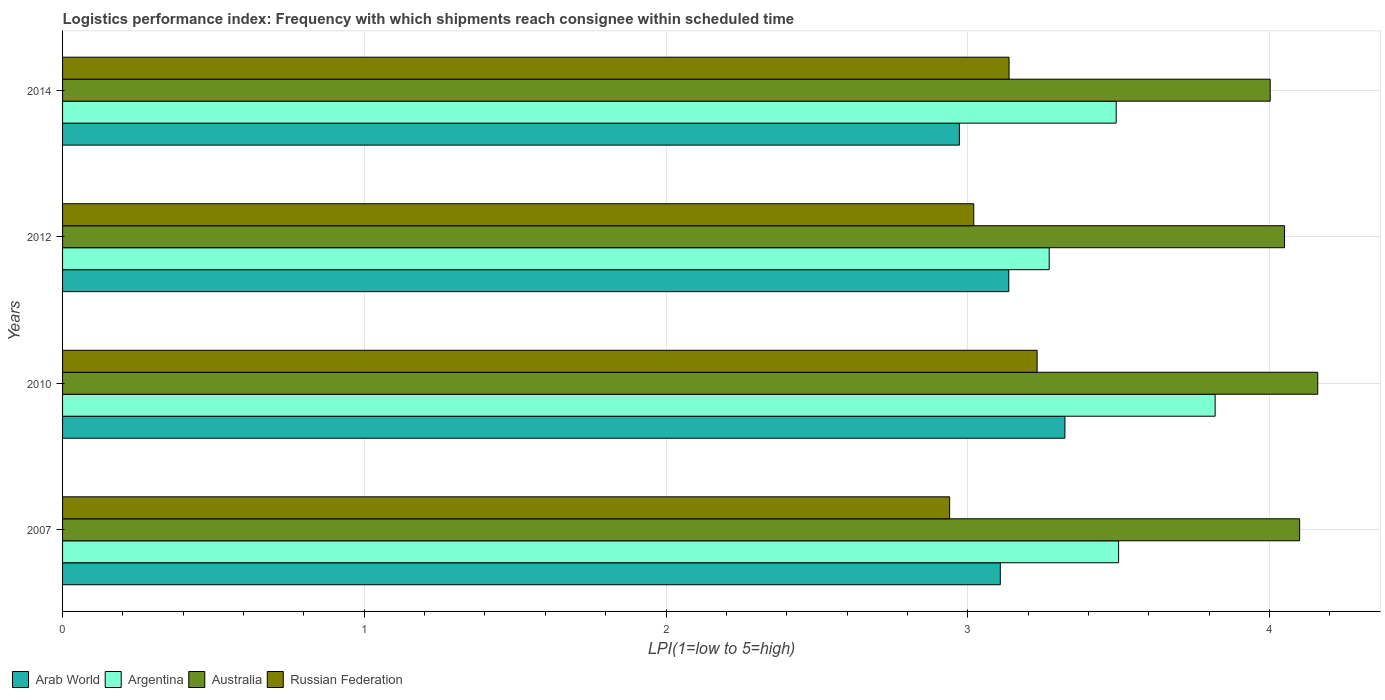Are the number of bars per tick equal to the number of legend labels?
Your response must be concise. Yes. How many bars are there on the 2nd tick from the top?
Your answer should be compact. 4. What is the logistics performance index in Australia in 2012?
Give a very brief answer. 4.05. Across all years, what is the maximum logistics performance index in Argentina?
Offer a terse response. 3.82. Across all years, what is the minimum logistics performance index in Arab World?
Make the answer very short. 2.97. What is the total logistics performance index in Arab World in the graph?
Provide a succinct answer. 12.54. What is the difference between the logistics performance index in Argentina in 2007 and that in 2012?
Make the answer very short. 0.23. What is the difference between the logistics performance index in Arab World in 2007 and the logistics performance index in Russian Federation in 2012?
Provide a short and direct response. 0.09. What is the average logistics performance index in Argentina per year?
Your response must be concise. 3.52. In the year 2010, what is the difference between the logistics performance index in Arab World and logistics performance index in Argentina?
Give a very brief answer. -0.5. In how many years, is the logistics performance index in Australia greater than 2.6 ?
Your answer should be very brief. 4. What is the ratio of the logistics performance index in Australia in 2007 to that in 2010?
Your answer should be compact. 0.99. What is the difference between the highest and the second highest logistics performance index in Argentina?
Your response must be concise. 0.32. What is the difference between the highest and the lowest logistics performance index in Argentina?
Your response must be concise. 0.55. In how many years, is the logistics performance index in Russian Federation greater than the average logistics performance index in Russian Federation taken over all years?
Offer a very short reply. 2. Is the sum of the logistics performance index in Arab World in 2012 and 2014 greater than the maximum logistics performance index in Russian Federation across all years?
Keep it short and to the point. Yes. Is it the case that in every year, the sum of the logistics performance index in Australia and logistics performance index in Russian Federation is greater than the sum of logistics performance index in Argentina and logistics performance index in Arab World?
Give a very brief answer. Yes. What does the 4th bar from the top in 2012 represents?
Your response must be concise. Arab World. How many bars are there?
Offer a very short reply. 16. Are all the bars in the graph horizontal?
Your response must be concise. Yes. How are the legend labels stacked?
Provide a succinct answer. Horizontal. What is the title of the graph?
Provide a short and direct response. Logistics performance index: Frequency with which shipments reach consignee within scheduled time. Does "Bahrain" appear as one of the legend labels in the graph?
Your answer should be very brief. No. What is the label or title of the X-axis?
Provide a short and direct response. LPI(1=low to 5=high). What is the LPI(1=low to 5=high) in Arab World in 2007?
Your response must be concise. 3.11. What is the LPI(1=low to 5=high) in Argentina in 2007?
Keep it short and to the point. 3.5. What is the LPI(1=low to 5=high) of Russian Federation in 2007?
Offer a very short reply. 2.94. What is the LPI(1=low to 5=high) in Arab World in 2010?
Your answer should be compact. 3.32. What is the LPI(1=low to 5=high) in Argentina in 2010?
Offer a very short reply. 3.82. What is the LPI(1=low to 5=high) in Australia in 2010?
Keep it short and to the point. 4.16. What is the LPI(1=low to 5=high) in Russian Federation in 2010?
Your answer should be compact. 3.23. What is the LPI(1=low to 5=high) in Arab World in 2012?
Provide a short and direct response. 3.14. What is the LPI(1=low to 5=high) in Argentina in 2012?
Ensure brevity in your answer.  3.27. What is the LPI(1=low to 5=high) of Australia in 2012?
Provide a succinct answer. 4.05. What is the LPI(1=low to 5=high) in Russian Federation in 2012?
Your answer should be compact. 3.02. What is the LPI(1=low to 5=high) of Arab World in 2014?
Keep it short and to the point. 2.97. What is the LPI(1=low to 5=high) of Argentina in 2014?
Your answer should be compact. 3.49. What is the LPI(1=low to 5=high) of Australia in 2014?
Make the answer very short. 4. What is the LPI(1=low to 5=high) of Russian Federation in 2014?
Offer a very short reply. 3.14. Across all years, what is the maximum LPI(1=low to 5=high) of Arab World?
Give a very brief answer. 3.32. Across all years, what is the maximum LPI(1=low to 5=high) of Argentina?
Provide a succinct answer. 3.82. Across all years, what is the maximum LPI(1=low to 5=high) of Australia?
Give a very brief answer. 4.16. Across all years, what is the maximum LPI(1=low to 5=high) in Russian Federation?
Ensure brevity in your answer.  3.23. Across all years, what is the minimum LPI(1=low to 5=high) in Arab World?
Your answer should be compact. 2.97. Across all years, what is the minimum LPI(1=low to 5=high) of Argentina?
Ensure brevity in your answer.  3.27. Across all years, what is the minimum LPI(1=low to 5=high) in Australia?
Offer a terse response. 4. Across all years, what is the minimum LPI(1=low to 5=high) in Russian Federation?
Offer a terse response. 2.94. What is the total LPI(1=low to 5=high) in Arab World in the graph?
Give a very brief answer. 12.54. What is the total LPI(1=low to 5=high) of Argentina in the graph?
Keep it short and to the point. 14.08. What is the total LPI(1=low to 5=high) in Australia in the graph?
Offer a terse response. 16.31. What is the total LPI(1=low to 5=high) of Russian Federation in the graph?
Your answer should be compact. 12.33. What is the difference between the LPI(1=low to 5=high) in Arab World in 2007 and that in 2010?
Provide a short and direct response. -0.21. What is the difference between the LPI(1=low to 5=high) of Argentina in 2007 and that in 2010?
Keep it short and to the point. -0.32. What is the difference between the LPI(1=low to 5=high) of Australia in 2007 and that in 2010?
Ensure brevity in your answer.  -0.06. What is the difference between the LPI(1=low to 5=high) in Russian Federation in 2007 and that in 2010?
Your answer should be very brief. -0.29. What is the difference between the LPI(1=low to 5=high) of Arab World in 2007 and that in 2012?
Your answer should be very brief. -0.03. What is the difference between the LPI(1=low to 5=high) in Argentina in 2007 and that in 2012?
Offer a terse response. 0.23. What is the difference between the LPI(1=low to 5=high) of Russian Federation in 2007 and that in 2012?
Keep it short and to the point. -0.08. What is the difference between the LPI(1=low to 5=high) in Arab World in 2007 and that in 2014?
Your response must be concise. 0.14. What is the difference between the LPI(1=low to 5=high) in Argentina in 2007 and that in 2014?
Provide a succinct answer. 0.01. What is the difference between the LPI(1=low to 5=high) in Australia in 2007 and that in 2014?
Provide a succinct answer. 0.1. What is the difference between the LPI(1=low to 5=high) of Russian Federation in 2007 and that in 2014?
Keep it short and to the point. -0.2. What is the difference between the LPI(1=low to 5=high) in Arab World in 2010 and that in 2012?
Ensure brevity in your answer.  0.19. What is the difference between the LPI(1=low to 5=high) of Argentina in 2010 and that in 2012?
Offer a terse response. 0.55. What is the difference between the LPI(1=low to 5=high) of Australia in 2010 and that in 2012?
Provide a short and direct response. 0.11. What is the difference between the LPI(1=low to 5=high) in Russian Federation in 2010 and that in 2012?
Your answer should be compact. 0.21. What is the difference between the LPI(1=low to 5=high) of Arab World in 2010 and that in 2014?
Provide a short and direct response. 0.35. What is the difference between the LPI(1=low to 5=high) in Argentina in 2010 and that in 2014?
Make the answer very short. 0.33. What is the difference between the LPI(1=low to 5=high) of Australia in 2010 and that in 2014?
Keep it short and to the point. 0.16. What is the difference between the LPI(1=low to 5=high) of Russian Federation in 2010 and that in 2014?
Offer a terse response. 0.09. What is the difference between the LPI(1=low to 5=high) of Arab World in 2012 and that in 2014?
Offer a very short reply. 0.16. What is the difference between the LPI(1=low to 5=high) of Argentina in 2012 and that in 2014?
Your answer should be compact. -0.22. What is the difference between the LPI(1=low to 5=high) of Australia in 2012 and that in 2014?
Your response must be concise. 0.05. What is the difference between the LPI(1=low to 5=high) of Russian Federation in 2012 and that in 2014?
Offer a terse response. -0.12. What is the difference between the LPI(1=low to 5=high) of Arab World in 2007 and the LPI(1=low to 5=high) of Argentina in 2010?
Your answer should be very brief. -0.71. What is the difference between the LPI(1=low to 5=high) of Arab World in 2007 and the LPI(1=low to 5=high) of Australia in 2010?
Your answer should be compact. -1.05. What is the difference between the LPI(1=low to 5=high) of Arab World in 2007 and the LPI(1=low to 5=high) of Russian Federation in 2010?
Make the answer very short. -0.12. What is the difference between the LPI(1=low to 5=high) of Argentina in 2007 and the LPI(1=low to 5=high) of Australia in 2010?
Offer a terse response. -0.66. What is the difference between the LPI(1=low to 5=high) in Argentina in 2007 and the LPI(1=low to 5=high) in Russian Federation in 2010?
Give a very brief answer. 0.27. What is the difference between the LPI(1=low to 5=high) in Australia in 2007 and the LPI(1=low to 5=high) in Russian Federation in 2010?
Provide a short and direct response. 0.87. What is the difference between the LPI(1=low to 5=high) of Arab World in 2007 and the LPI(1=low to 5=high) of Argentina in 2012?
Your answer should be compact. -0.16. What is the difference between the LPI(1=low to 5=high) in Arab World in 2007 and the LPI(1=low to 5=high) in Australia in 2012?
Your answer should be compact. -0.94. What is the difference between the LPI(1=low to 5=high) in Arab World in 2007 and the LPI(1=low to 5=high) in Russian Federation in 2012?
Offer a very short reply. 0.09. What is the difference between the LPI(1=low to 5=high) in Argentina in 2007 and the LPI(1=low to 5=high) in Australia in 2012?
Make the answer very short. -0.55. What is the difference between the LPI(1=low to 5=high) of Argentina in 2007 and the LPI(1=low to 5=high) of Russian Federation in 2012?
Keep it short and to the point. 0.48. What is the difference between the LPI(1=low to 5=high) in Australia in 2007 and the LPI(1=low to 5=high) in Russian Federation in 2012?
Your answer should be very brief. 1.08. What is the difference between the LPI(1=low to 5=high) of Arab World in 2007 and the LPI(1=low to 5=high) of Argentina in 2014?
Offer a very short reply. -0.38. What is the difference between the LPI(1=low to 5=high) in Arab World in 2007 and the LPI(1=low to 5=high) in Australia in 2014?
Provide a succinct answer. -0.89. What is the difference between the LPI(1=low to 5=high) of Arab World in 2007 and the LPI(1=low to 5=high) of Russian Federation in 2014?
Your response must be concise. -0.03. What is the difference between the LPI(1=low to 5=high) of Argentina in 2007 and the LPI(1=low to 5=high) of Australia in 2014?
Keep it short and to the point. -0.5. What is the difference between the LPI(1=low to 5=high) in Argentina in 2007 and the LPI(1=low to 5=high) in Russian Federation in 2014?
Ensure brevity in your answer.  0.36. What is the difference between the LPI(1=low to 5=high) of Arab World in 2010 and the LPI(1=low to 5=high) of Argentina in 2012?
Give a very brief answer. 0.05. What is the difference between the LPI(1=low to 5=high) of Arab World in 2010 and the LPI(1=low to 5=high) of Australia in 2012?
Offer a very short reply. -0.73. What is the difference between the LPI(1=low to 5=high) in Arab World in 2010 and the LPI(1=low to 5=high) in Russian Federation in 2012?
Provide a succinct answer. 0.3. What is the difference between the LPI(1=low to 5=high) of Argentina in 2010 and the LPI(1=low to 5=high) of Australia in 2012?
Your response must be concise. -0.23. What is the difference between the LPI(1=low to 5=high) in Argentina in 2010 and the LPI(1=low to 5=high) in Russian Federation in 2012?
Keep it short and to the point. 0.8. What is the difference between the LPI(1=low to 5=high) of Australia in 2010 and the LPI(1=low to 5=high) of Russian Federation in 2012?
Provide a succinct answer. 1.14. What is the difference between the LPI(1=low to 5=high) in Arab World in 2010 and the LPI(1=low to 5=high) in Argentina in 2014?
Make the answer very short. -0.17. What is the difference between the LPI(1=low to 5=high) in Arab World in 2010 and the LPI(1=low to 5=high) in Australia in 2014?
Offer a terse response. -0.68. What is the difference between the LPI(1=low to 5=high) in Arab World in 2010 and the LPI(1=low to 5=high) in Russian Federation in 2014?
Your response must be concise. 0.19. What is the difference between the LPI(1=low to 5=high) in Argentina in 2010 and the LPI(1=low to 5=high) in Australia in 2014?
Provide a short and direct response. -0.18. What is the difference between the LPI(1=low to 5=high) in Argentina in 2010 and the LPI(1=low to 5=high) in Russian Federation in 2014?
Make the answer very short. 0.68. What is the difference between the LPI(1=low to 5=high) in Australia in 2010 and the LPI(1=low to 5=high) in Russian Federation in 2014?
Ensure brevity in your answer.  1.02. What is the difference between the LPI(1=low to 5=high) in Arab World in 2012 and the LPI(1=low to 5=high) in Argentina in 2014?
Offer a very short reply. -0.36. What is the difference between the LPI(1=low to 5=high) of Arab World in 2012 and the LPI(1=low to 5=high) of Australia in 2014?
Provide a short and direct response. -0.87. What is the difference between the LPI(1=low to 5=high) of Arab World in 2012 and the LPI(1=low to 5=high) of Russian Federation in 2014?
Make the answer very short. -0. What is the difference between the LPI(1=low to 5=high) in Argentina in 2012 and the LPI(1=low to 5=high) in Australia in 2014?
Your response must be concise. -0.73. What is the difference between the LPI(1=low to 5=high) in Argentina in 2012 and the LPI(1=low to 5=high) in Russian Federation in 2014?
Your answer should be compact. 0.13. What is the difference between the LPI(1=low to 5=high) of Australia in 2012 and the LPI(1=low to 5=high) of Russian Federation in 2014?
Your answer should be very brief. 0.91. What is the average LPI(1=low to 5=high) in Arab World per year?
Ensure brevity in your answer.  3.13. What is the average LPI(1=low to 5=high) in Argentina per year?
Offer a terse response. 3.52. What is the average LPI(1=low to 5=high) in Australia per year?
Provide a short and direct response. 4.08. What is the average LPI(1=low to 5=high) of Russian Federation per year?
Give a very brief answer. 3.08. In the year 2007, what is the difference between the LPI(1=low to 5=high) of Arab World and LPI(1=low to 5=high) of Argentina?
Provide a succinct answer. -0.39. In the year 2007, what is the difference between the LPI(1=low to 5=high) of Arab World and LPI(1=low to 5=high) of Australia?
Give a very brief answer. -0.99. In the year 2007, what is the difference between the LPI(1=low to 5=high) of Arab World and LPI(1=low to 5=high) of Russian Federation?
Offer a terse response. 0.17. In the year 2007, what is the difference between the LPI(1=low to 5=high) in Argentina and LPI(1=low to 5=high) in Australia?
Make the answer very short. -0.6. In the year 2007, what is the difference between the LPI(1=low to 5=high) in Argentina and LPI(1=low to 5=high) in Russian Federation?
Offer a very short reply. 0.56. In the year 2007, what is the difference between the LPI(1=low to 5=high) of Australia and LPI(1=low to 5=high) of Russian Federation?
Offer a very short reply. 1.16. In the year 2010, what is the difference between the LPI(1=low to 5=high) of Arab World and LPI(1=low to 5=high) of Argentina?
Your response must be concise. -0.5. In the year 2010, what is the difference between the LPI(1=low to 5=high) of Arab World and LPI(1=low to 5=high) of Australia?
Keep it short and to the point. -0.84. In the year 2010, what is the difference between the LPI(1=low to 5=high) of Arab World and LPI(1=low to 5=high) of Russian Federation?
Offer a terse response. 0.09. In the year 2010, what is the difference between the LPI(1=low to 5=high) in Argentina and LPI(1=low to 5=high) in Australia?
Your answer should be compact. -0.34. In the year 2010, what is the difference between the LPI(1=low to 5=high) of Argentina and LPI(1=low to 5=high) of Russian Federation?
Provide a short and direct response. 0.59. In the year 2012, what is the difference between the LPI(1=low to 5=high) in Arab World and LPI(1=low to 5=high) in Argentina?
Make the answer very short. -0.13. In the year 2012, what is the difference between the LPI(1=low to 5=high) of Arab World and LPI(1=low to 5=high) of Australia?
Offer a very short reply. -0.91. In the year 2012, what is the difference between the LPI(1=low to 5=high) in Arab World and LPI(1=low to 5=high) in Russian Federation?
Ensure brevity in your answer.  0.12. In the year 2012, what is the difference between the LPI(1=low to 5=high) of Argentina and LPI(1=low to 5=high) of Australia?
Keep it short and to the point. -0.78. In the year 2012, what is the difference between the LPI(1=low to 5=high) in Argentina and LPI(1=low to 5=high) in Russian Federation?
Keep it short and to the point. 0.25. In the year 2012, what is the difference between the LPI(1=low to 5=high) of Australia and LPI(1=low to 5=high) of Russian Federation?
Your response must be concise. 1.03. In the year 2014, what is the difference between the LPI(1=low to 5=high) in Arab World and LPI(1=low to 5=high) in Argentina?
Make the answer very short. -0.52. In the year 2014, what is the difference between the LPI(1=low to 5=high) of Arab World and LPI(1=low to 5=high) of Australia?
Offer a very short reply. -1.03. In the year 2014, what is the difference between the LPI(1=low to 5=high) of Arab World and LPI(1=low to 5=high) of Russian Federation?
Offer a terse response. -0.16. In the year 2014, what is the difference between the LPI(1=low to 5=high) in Argentina and LPI(1=low to 5=high) in Australia?
Offer a very short reply. -0.51. In the year 2014, what is the difference between the LPI(1=low to 5=high) of Argentina and LPI(1=low to 5=high) of Russian Federation?
Offer a very short reply. 0.35. In the year 2014, what is the difference between the LPI(1=low to 5=high) of Australia and LPI(1=low to 5=high) of Russian Federation?
Your response must be concise. 0.87. What is the ratio of the LPI(1=low to 5=high) of Arab World in 2007 to that in 2010?
Your answer should be compact. 0.94. What is the ratio of the LPI(1=low to 5=high) in Argentina in 2007 to that in 2010?
Give a very brief answer. 0.92. What is the ratio of the LPI(1=low to 5=high) of Australia in 2007 to that in 2010?
Your response must be concise. 0.99. What is the ratio of the LPI(1=low to 5=high) in Russian Federation in 2007 to that in 2010?
Offer a very short reply. 0.91. What is the ratio of the LPI(1=low to 5=high) in Arab World in 2007 to that in 2012?
Give a very brief answer. 0.99. What is the ratio of the LPI(1=low to 5=high) in Argentina in 2007 to that in 2012?
Your response must be concise. 1.07. What is the ratio of the LPI(1=low to 5=high) in Australia in 2007 to that in 2012?
Your answer should be compact. 1.01. What is the ratio of the LPI(1=low to 5=high) in Russian Federation in 2007 to that in 2012?
Offer a very short reply. 0.97. What is the ratio of the LPI(1=low to 5=high) of Arab World in 2007 to that in 2014?
Your response must be concise. 1.05. What is the ratio of the LPI(1=low to 5=high) of Argentina in 2007 to that in 2014?
Ensure brevity in your answer.  1. What is the ratio of the LPI(1=low to 5=high) of Australia in 2007 to that in 2014?
Your response must be concise. 1.02. What is the ratio of the LPI(1=low to 5=high) in Russian Federation in 2007 to that in 2014?
Your response must be concise. 0.94. What is the ratio of the LPI(1=low to 5=high) of Arab World in 2010 to that in 2012?
Your answer should be very brief. 1.06. What is the ratio of the LPI(1=low to 5=high) in Argentina in 2010 to that in 2012?
Your response must be concise. 1.17. What is the ratio of the LPI(1=low to 5=high) in Australia in 2010 to that in 2012?
Provide a short and direct response. 1.03. What is the ratio of the LPI(1=low to 5=high) of Russian Federation in 2010 to that in 2012?
Your response must be concise. 1.07. What is the ratio of the LPI(1=low to 5=high) in Arab World in 2010 to that in 2014?
Provide a short and direct response. 1.12. What is the ratio of the LPI(1=low to 5=high) of Argentina in 2010 to that in 2014?
Your answer should be very brief. 1.09. What is the ratio of the LPI(1=low to 5=high) in Australia in 2010 to that in 2014?
Keep it short and to the point. 1.04. What is the ratio of the LPI(1=low to 5=high) in Russian Federation in 2010 to that in 2014?
Your answer should be very brief. 1.03. What is the ratio of the LPI(1=low to 5=high) in Arab World in 2012 to that in 2014?
Ensure brevity in your answer.  1.06. What is the ratio of the LPI(1=low to 5=high) in Argentina in 2012 to that in 2014?
Your answer should be compact. 0.94. What is the ratio of the LPI(1=low to 5=high) in Australia in 2012 to that in 2014?
Your response must be concise. 1.01. What is the ratio of the LPI(1=low to 5=high) in Russian Federation in 2012 to that in 2014?
Your response must be concise. 0.96. What is the difference between the highest and the second highest LPI(1=low to 5=high) in Arab World?
Your answer should be compact. 0.19. What is the difference between the highest and the second highest LPI(1=low to 5=high) in Argentina?
Provide a short and direct response. 0.32. What is the difference between the highest and the second highest LPI(1=low to 5=high) in Russian Federation?
Your response must be concise. 0.09. What is the difference between the highest and the lowest LPI(1=low to 5=high) in Arab World?
Your answer should be compact. 0.35. What is the difference between the highest and the lowest LPI(1=low to 5=high) of Argentina?
Provide a succinct answer. 0.55. What is the difference between the highest and the lowest LPI(1=low to 5=high) in Australia?
Give a very brief answer. 0.16. What is the difference between the highest and the lowest LPI(1=low to 5=high) in Russian Federation?
Provide a short and direct response. 0.29. 